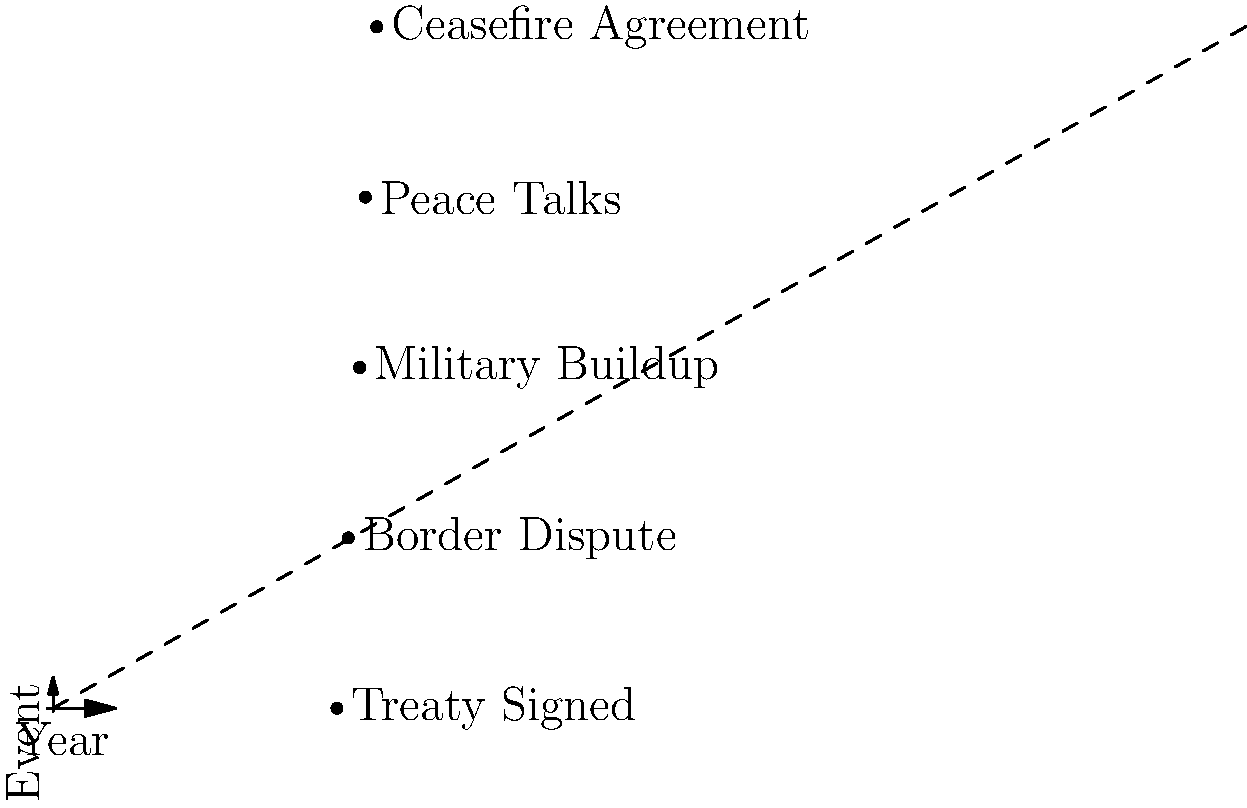Based on the timeline of key events in the regional conflict, what conclusion can be drawn about the overall trend of the situation between 2015 and 2022? To interpret the timeline and draw a conclusion about the overall trend, let's analyze the events chronologically:

1. 2015: Treaty Signed - This indicates a positive start, suggesting an attempt at peaceful resolution.

2. 2017: Border Dispute - This event shows a deterioration in relations, likely causing increased tensions.

3. 2019: Military Buildup - This suggests further escalation of the conflict, with both sides potentially preparing for armed confrontation.

4. 2020: Peace Talks - Despite the military buildup, this event indicates a renewed effort to resolve the conflict diplomatically.

5. 2022: Ceasefire Agreement - This final event suggests a de-escalation of the conflict and a move towards peace.

Analyzing the progression:
- The situation started positively but quickly deteriorated (2015-2019).
- There was a turning point in 2020 with peace talks.
- The trend concluded with a positive development in 2022.

The overall trend shows an initial deterioration followed by efforts to resolve the conflict peacefully. The dashed line in the graph also visually represents this trend, moving upward (worsening) before leveling off and slightly improving towards the end.
Answer: Initial deterioration followed by de-escalation and efforts towards peace. 